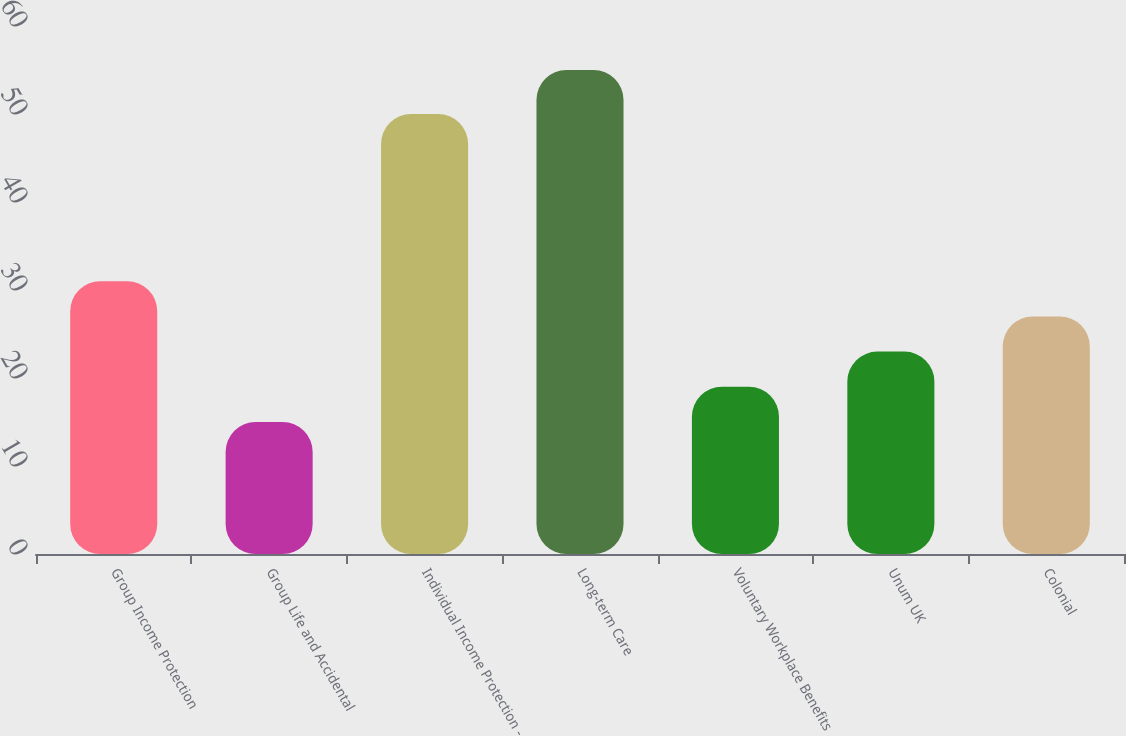Convert chart. <chart><loc_0><loc_0><loc_500><loc_500><bar_chart><fcel>Group Income Protection<fcel>Group Life and Accidental<fcel>Individual Income Protection -<fcel>Long-term Care<fcel>Voluntary Workplace Benefits<fcel>Unum UK<fcel>Colonial<nl><fcel>31<fcel>15<fcel>50<fcel>55<fcel>19<fcel>23<fcel>27<nl></chart> 